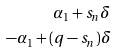Convert formula to latex. <formula><loc_0><loc_0><loc_500><loc_500>\alpha _ { 1 } + s _ { n } \delta \\ - \alpha _ { 1 } + ( q - s _ { n } ) \delta</formula> 